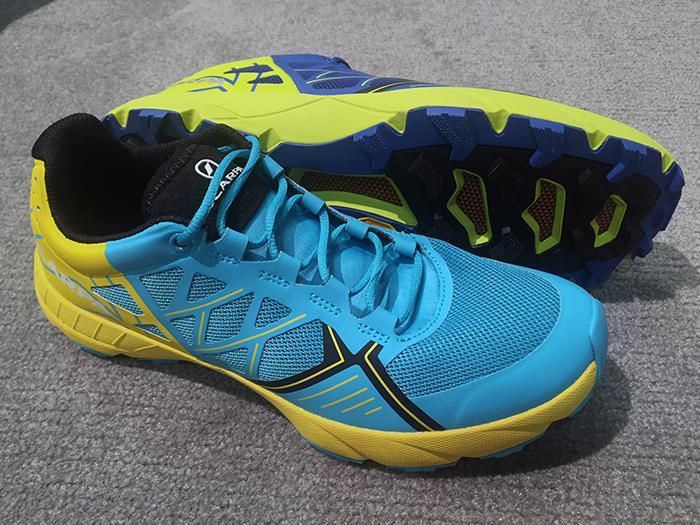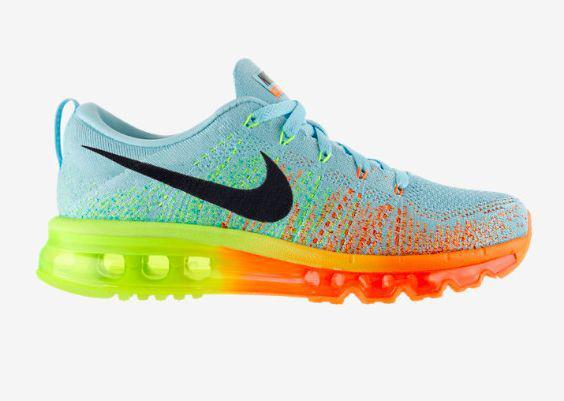The first image is the image on the left, the second image is the image on the right. Considering the images on both sides, is "A shoe is sitting on top of another object." valid? Answer yes or no. No. The first image is the image on the left, the second image is the image on the right. Analyze the images presented: Is the assertion "There are exactly two sneakers." valid? Answer yes or no. No. 